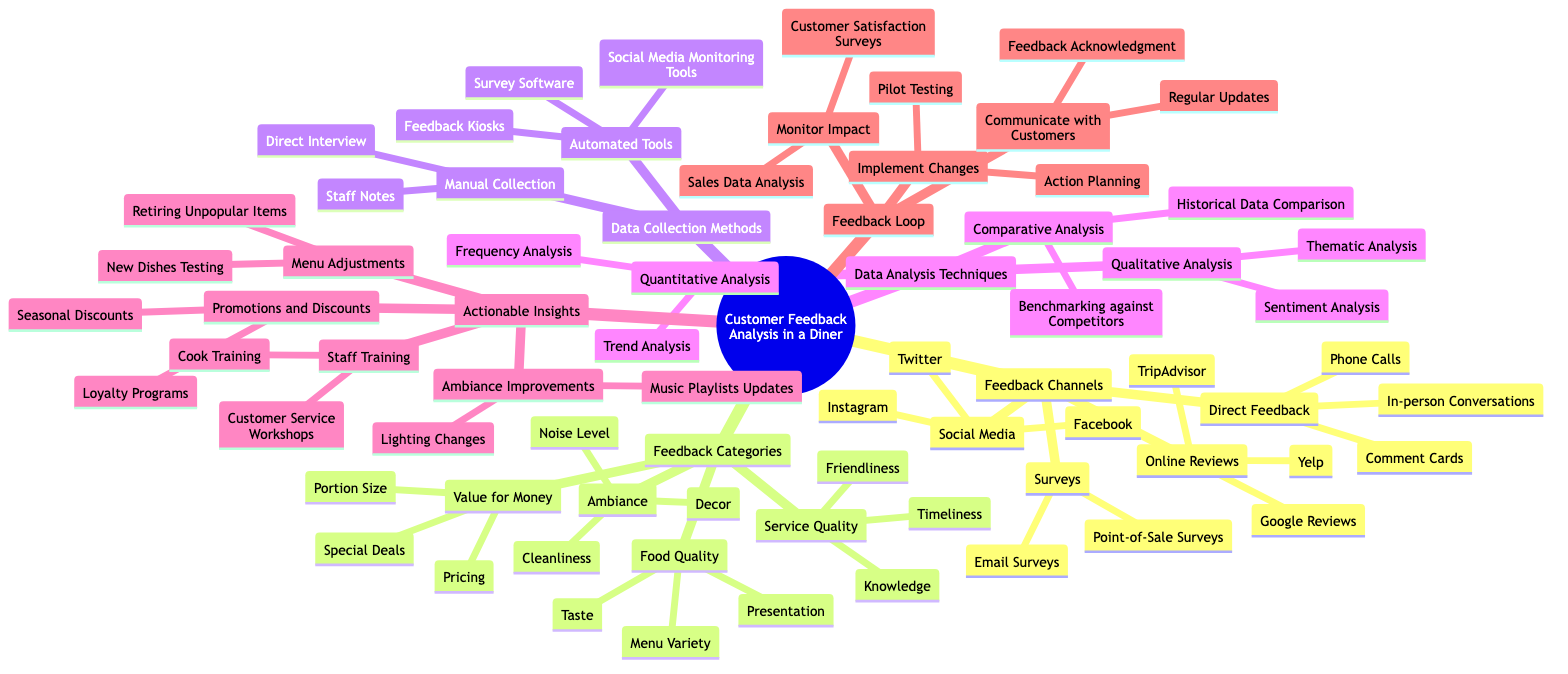What are three feedback channels mentioned in the diagram? The diagram lists four main feedback channels: Online Reviews, Social Media, Direct Feedback, and Surveys. I can find examples for these, which include Online Reviews consisting of Yelp, Google Reviews, and TripAdvisor. Therefore, three feedback channels can be Online Reviews, Social Media, and Direct Feedback.
Answer: Online Reviews, Social Media, Direct Feedback How many feedback categories are there in the diagram? Upon inspecting the diagram, there are four distinct feedback categories listed: Food Quality, Service Quality, Ambiance, and Value for Money. Counting these gives a total of four categories.
Answer: 4 What could be an actionable insight for improving the ambiance? The diagram indicates several actionable insights, particularly for ambiance improvements. One specific example listed under Ambiance Improvements is Lighting Changes, which suggests how ambiance can be enhanced.
Answer: Lighting Changes Which data analysis technique includes examining historical data? Among the data analysis techniques, the Comparative Analysis category includes "Historical Data Comparison," indicating that this technique specifically involves looking at data from the past to derive insights.
Answer: Historical Data Comparison Name one customer feedback channel that utilizes automated tools. In the "Data Collection Methods" section, Automated Tools include items like "Feedback Kiosks" and "Survey Software." Selecting one example from this category provides "Feedback Kiosks" as an automated tool for gathering feedback.
Answer: Feedback Kiosks What are two methods for collecting data mentioned in the diagram? The diagram presents two main categories of data collection: Manual Collection and Automated Tools. For Manual Collection, options like Staff Notes and Direct Interview are provided, while Automated Tools include Feedback Kiosks and Survey Software. Therefore, I can list one from each category: Staff Notes and Feedback Kiosks.
Answer: Staff Notes, Feedback Kiosks How is customer satisfaction monitored after implementing changes? In the Feedback Loop section of the diagram, after implementing changes, one of the ways to monitor customer satisfaction is through "Customer Satisfaction Surveys." This indicates how diners assess the effectiveness of changes made.
Answer: Customer Satisfaction Surveys What do the steps "Implement Changes" and "Monitor Impact" collectively describe in the diagram? The steps "Implement Changes" and "Monitor Impact" are part of the Feedback Loop category which describes the process that starts with implementing changes based on customer feedback followed by monitoring the effectiveness of those changes. This sequence indicates a continuous improvement cycle.
Answer: Feedback Loop 